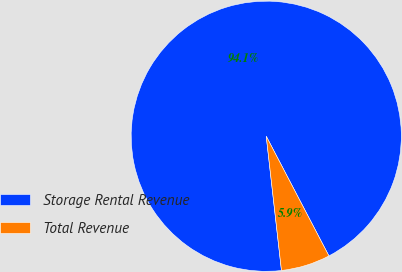<chart> <loc_0><loc_0><loc_500><loc_500><pie_chart><fcel>Storage Rental Revenue<fcel>Total Revenue<nl><fcel>94.12%<fcel>5.88%<nl></chart> 